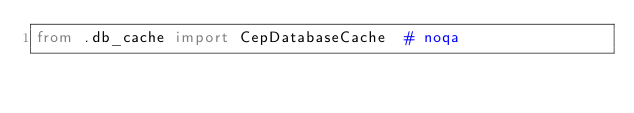Convert code to text. <code><loc_0><loc_0><loc_500><loc_500><_Python_>from .db_cache import CepDatabaseCache  # noqa
</code> 